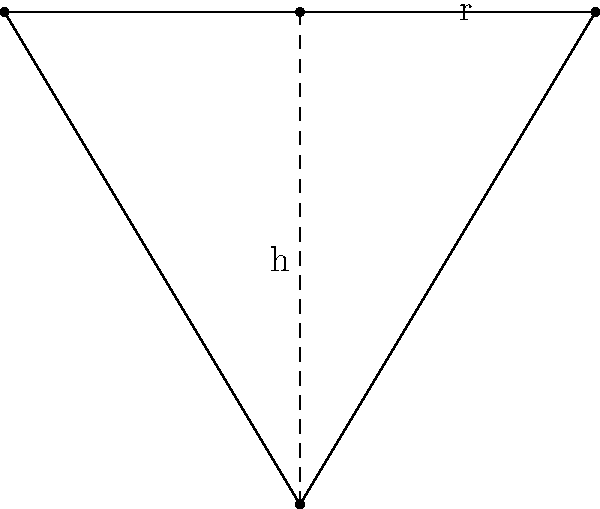You're designing a new conical tea strainer for your tea house. The strainer has a radius of 3 cm at the base and a height of 5 cm. To optimize brewing efficiency, you need to calculate the surface area of the strainer (excluding the circular base). How does the surface area (in cm²) of this conical strainer compare to a cylindrical strainer with the same base radius and height? Let's approach this step-by-step:

1) For a cone, the surface area (excluding the base) is given by the formula:
   $$A = \pi r \sqrt{r^2 + h^2}$$
   where $r$ is the radius of the base and $h$ is the height.

2) Given values: $r = 3$ cm, $h = 5$ cm

3) Substituting these values:
   $$A = \pi \cdot 3 \cdot \sqrt{3^2 + 5^2}$$
   $$A = 3\pi \sqrt{9 + 25}$$
   $$A = 3\pi \sqrt{34}$$
   $$A \approx 55.77 \text{ cm}^2$$

4) For a cylinder, the surface area (excluding the bases) is given by:
   $$A = 2\pi r h$$

5) Substituting the same values:
   $$A = 2\pi \cdot 3 \cdot 5 = 30\pi \approx 94.25 \text{ cm}^2$$

6) Comparing the two:
   Conical strainer: 55.77 cm²
   Cylindrical strainer: 94.25 cm²

7) The difference is:
   $$94.25 - 55.77 = 38.48 \text{ cm}^2$$

Therefore, the surface area of the conical strainer is approximately 38.48 cm² less than that of a cylindrical strainer with the same base radius and height.
Answer: 38.48 cm² less 